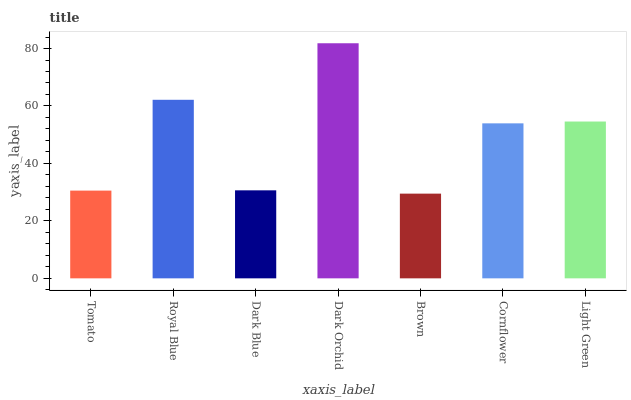Is Brown the minimum?
Answer yes or no. Yes. Is Dark Orchid the maximum?
Answer yes or no. Yes. Is Royal Blue the minimum?
Answer yes or no. No. Is Royal Blue the maximum?
Answer yes or no. No. Is Royal Blue greater than Tomato?
Answer yes or no. Yes. Is Tomato less than Royal Blue?
Answer yes or no. Yes. Is Tomato greater than Royal Blue?
Answer yes or no. No. Is Royal Blue less than Tomato?
Answer yes or no. No. Is Cornflower the high median?
Answer yes or no. Yes. Is Cornflower the low median?
Answer yes or no. Yes. Is Royal Blue the high median?
Answer yes or no. No. Is Dark Orchid the low median?
Answer yes or no. No. 